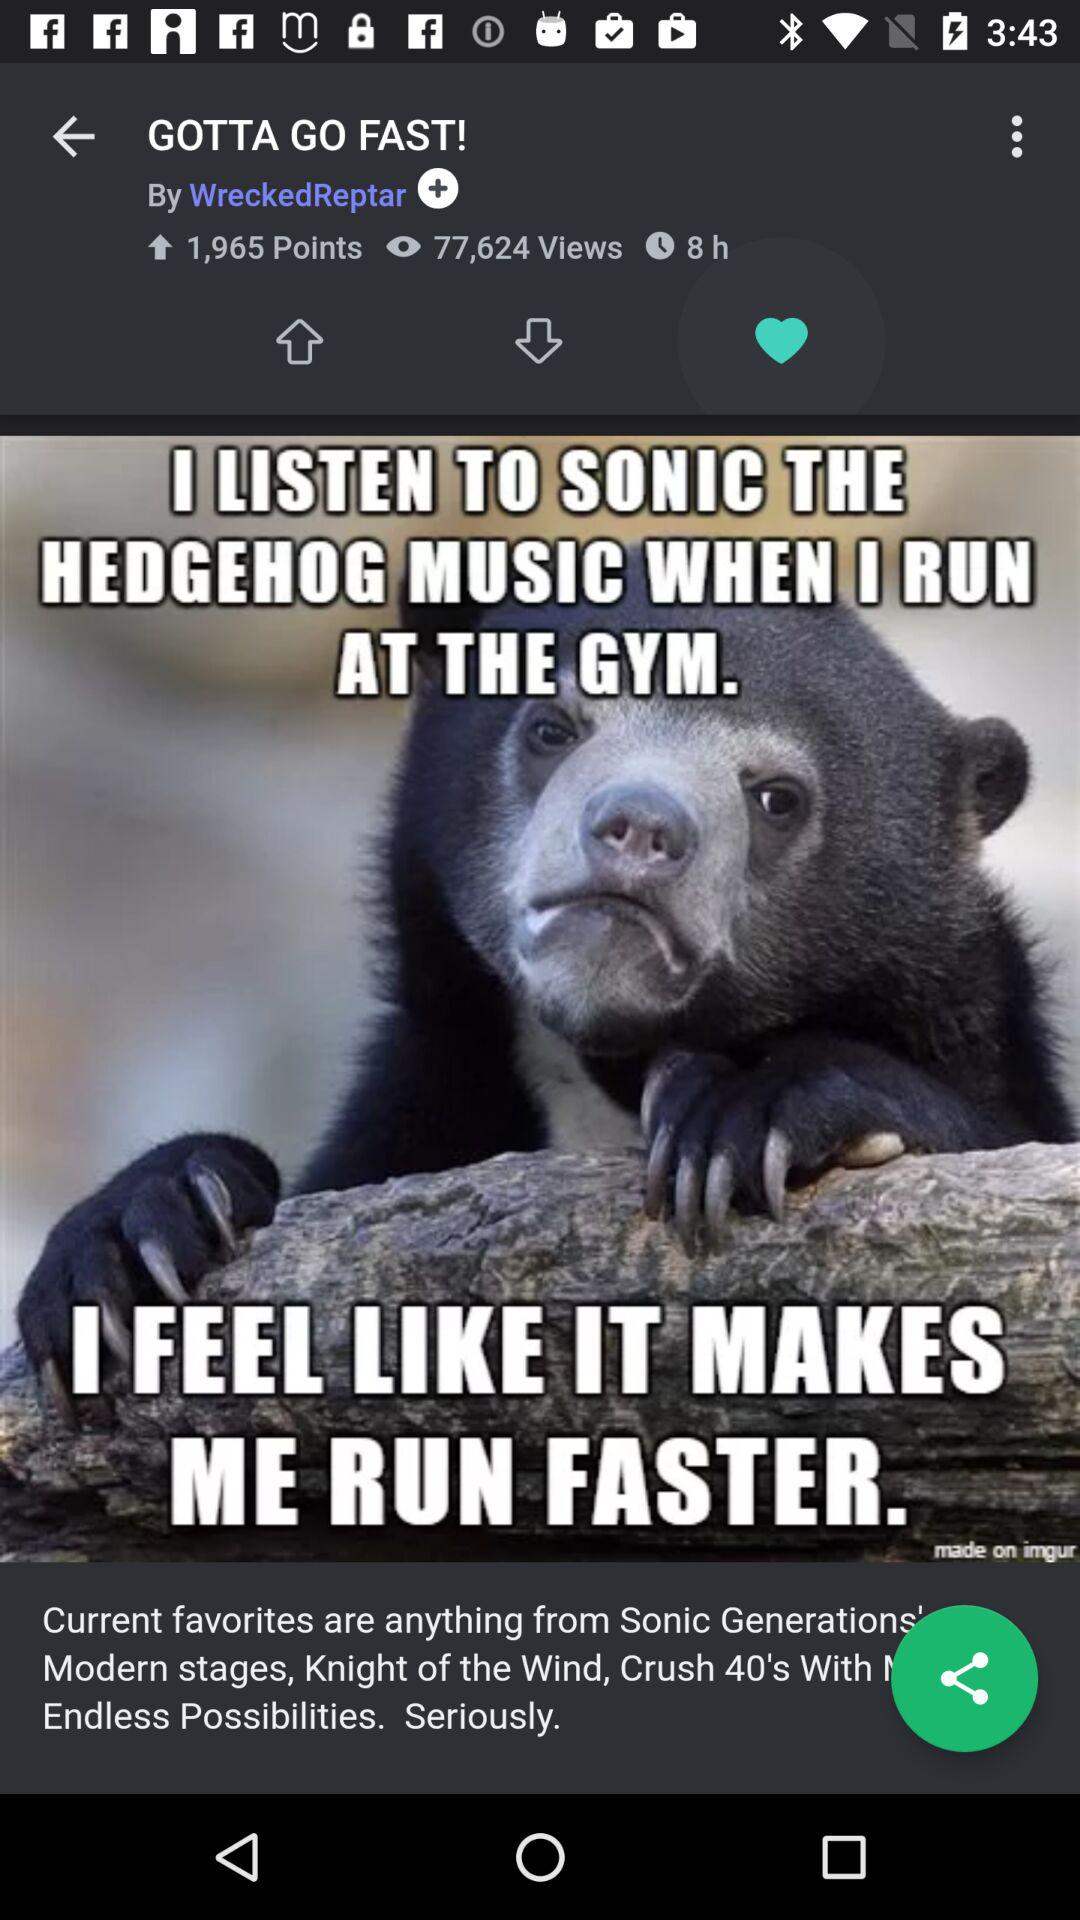What is the total number of views? The total number of views is 77,624. 